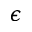<formula> <loc_0><loc_0><loc_500><loc_500>\epsilon</formula> 